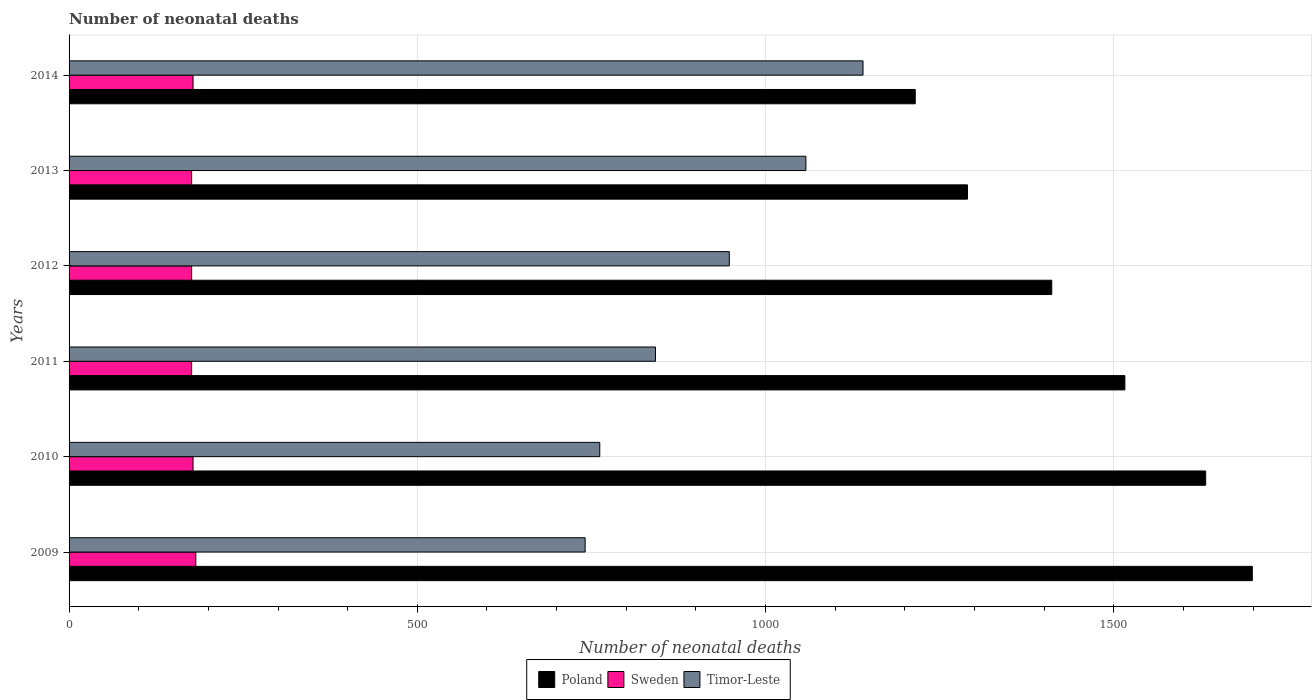Are the number of bars per tick equal to the number of legend labels?
Ensure brevity in your answer.  Yes. How many bars are there on the 4th tick from the top?
Your response must be concise. 3. In how many cases, is the number of bars for a given year not equal to the number of legend labels?
Provide a succinct answer. 0. What is the number of neonatal deaths in in Sweden in 2010?
Make the answer very short. 178. Across all years, what is the maximum number of neonatal deaths in in Poland?
Offer a very short reply. 1699. Across all years, what is the minimum number of neonatal deaths in in Poland?
Keep it short and to the point. 1215. In which year was the number of neonatal deaths in in Sweden maximum?
Your response must be concise. 2009. In which year was the number of neonatal deaths in in Sweden minimum?
Give a very brief answer. 2011. What is the total number of neonatal deaths in in Poland in the graph?
Your answer should be very brief. 8763. What is the difference between the number of neonatal deaths in in Sweden in 2012 and that in 2014?
Ensure brevity in your answer.  -2. What is the difference between the number of neonatal deaths in in Poland in 2010 and the number of neonatal deaths in in Timor-Leste in 2014?
Your response must be concise. 492. What is the average number of neonatal deaths in in Timor-Leste per year?
Your response must be concise. 915.17. In the year 2014, what is the difference between the number of neonatal deaths in in Poland and number of neonatal deaths in in Sweden?
Provide a short and direct response. 1037. What is the ratio of the number of neonatal deaths in in Poland in 2012 to that in 2013?
Your response must be concise. 1.09. Is the number of neonatal deaths in in Sweden in 2013 less than that in 2014?
Make the answer very short. Yes. Is the sum of the number of neonatal deaths in in Timor-Leste in 2009 and 2010 greater than the maximum number of neonatal deaths in in Sweden across all years?
Provide a short and direct response. Yes. What does the 1st bar from the top in 2012 represents?
Your response must be concise. Timor-Leste. Is it the case that in every year, the sum of the number of neonatal deaths in in Timor-Leste and number of neonatal deaths in in Sweden is greater than the number of neonatal deaths in in Poland?
Your response must be concise. No. How many bars are there?
Make the answer very short. 18. Are all the bars in the graph horizontal?
Give a very brief answer. Yes. How many years are there in the graph?
Keep it short and to the point. 6. What is the difference between two consecutive major ticks on the X-axis?
Give a very brief answer. 500. Does the graph contain any zero values?
Your response must be concise. No. Does the graph contain grids?
Keep it short and to the point. Yes. Where does the legend appear in the graph?
Provide a short and direct response. Bottom center. What is the title of the graph?
Your answer should be very brief. Number of neonatal deaths. Does "Colombia" appear as one of the legend labels in the graph?
Your answer should be compact. No. What is the label or title of the X-axis?
Ensure brevity in your answer.  Number of neonatal deaths. What is the label or title of the Y-axis?
Provide a succinct answer. Years. What is the Number of neonatal deaths in Poland in 2009?
Give a very brief answer. 1699. What is the Number of neonatal deaths of Sweden in 2009?
Your answer should be very brief. 182. What is the Number of neonatal deaths in Timor-Leste in 2009?
Give a very brief answer. 741. What is the Number of neonatal deaths of Poland in 2010?
Make the answer very short. 1632. What is the Number of neonatal deaths of Sweden in 2010?
Provide a succinct answer. 178. What is the Number of neonatal deaths of Timor-Leste in 2010?
Provide a succinct answer. 762. What is the Number of neonatal deaths of Poland in 2011?
Make the answer very short. 1516. What is the Number of neonatal deaths of Sweden in 2011?
Your answer should be very brief. 176. What is the Number of neonatal deaths in Timor-Leste in 2011?
Ensure brevity in your answer.  842. What is the Number of neonatal deaths in Poland in 2012?
Keep it short and to the point. 1411. What is the Number of neonatal deaths in Sweden in 2012?
Ensure brevity in your answer.  176. What is the Number of neonatal deaths in Timor-Leste in 2012?
Provide a short and direct response. 948. What is the Number of neonatal deaths in Poland in 2013?
Keep it short and to the point. 1290. What is the Number of neonatal deaths in Sweden in 2013?
Keep it short and to the point. 176. What is the Number of neonatal deaths of Timor-Leste in 2013?
Make the answer very short. 1058. What is the Number of neonatal deaths of Poland in 2014?
Provide a succinct answer. 1215. What is the Number of neonatal deaths in Sweden in 2014?
Provide a short and direct response. 178. What is the Number of neonatal deaths of Timor-Leste in 2014?
Ensure brevity in your answer.  1140. Across all years, what is the maximum Number of neonatal deaths of Poland?
Keep it short and to the point. 1699. Across all years, what is the maximum Number of neonatal deaths of Sweden?
Your response must be concise. 182. Across all years, what is the maximum Number of neonatal deaths of Timor-Leste?
Ensure brevity in your answer.  1140. Across all years, what is the minimum Number of neonatal deaths of Poland?
Give a very brief answer. 1215. Across all years, what is the minimum Number of neonatal deaths of Sweden?
Keep it short and to the point. 176. Across all years, what is the minimum Number of neonatal deaths of Timor-Leste?
Your answer should be very brief. 741. What is the total Number of neonatal deaths in Poland in the graph?
Make the answer very short. 8763. What is the total Number of neonatal deaths of Sweden in the graph?
Ensure brevity in your answer.  1066. What is the total Number of neonatal deaths in Timor-Leste in the graph?
Provide a short and direct response. 5491. What is the difference between the Number of neonatal deaths of Poland in 2009 and that in 2010?
Give a very brief answer. 67. What is the difference between the Number of neonatal deaths of Sweden in 2009 and that in 2010?
Make the answer very short. 4. What is the difference between the Number of neonatal deaths in Poland in 2009 and that in 2011?
Provide a short and direct response. 183. What is the difference between the Number of neonatal deaths of Sweden in 2009 and that in 2011?
Provide a short and direct response. 6. What is the difference between the Number of neonatal deaths of Timor-Leste in 2009 and that in 2011?
Ensure brevity in your answer.  -101. What is the difference between the Number of neonatal deaths of Poland in 2009 and that in 2012?
Your answer should be compact. 288. What is the difference between the Number of neonatal deaths in Timor-Leste in 2009 and that in 2012?
Provide a short and direct response. -207. What is the difference between the Number of neonatal deaths of Poland in 2009 and that in 2013?
Ensure brevity in your answer.  409. What is the difference between the Number of neonatal deaths in Timor-Leste in 2009 and that in 2013?
Ensure brevity in your answer.  -317. What is the difference between the Number of neonatal deaths of Poland in 2009 and that in 2014?
Offer a very short reply. 484. What is the difference between the Number of neonatal deaths in Sweden in 2009 and that in 2014?
Give a very brief answer. 4. What is the difference between the Number of neonatal deaths of Timor-Leste in 2009 and that in 2014?
Provide a succinct answer. -399. What is the difference between the Number of neonatal deaths in Poland in 2010 and that in 2011?
Your response must be concise. 116. What is the difference between the Number of neonatal deaths in Sweden in 2010 and that in 2011?
Make the answer very short. 2. What is the difference between the Number of neonatal deaths of Timor-Leste in 2010 and that in 2011?
Keep it short and to the point. -80. What is the difference between the Number of neonatal deaths of Poland in 2010 and that in 2012?
Your answer should be very brief. 221. What is the difference between the Number of neonatal deaths of Sweden in 2010 and that in 2012?
Offer a very short reply. 2. What is the difference between the Number of neonatal deaths of Timor-Leste in 2010 and that in 2012?
Provide a succinct answer. -186. What is the difference between the Number of neonatal deaths of Poland in 2010 and that in 2013?
Give a very brief answer. 342. What is the difference between the Number of neonatal deaths in Sweden in 2010 and that in 2013?
Offer a terse response. 2. What is the difference between the Number of neonatal deaths in Timor-Leste in 2010 and that in 2013?
Give a very brief answer. -296. What is the difference between the Number of neonatal deaths of Poland in 2010 and that in 2014?
Offer a terse response. 417. What is the difference between the Number of neonatal deaths in Sweden in 2010 and that in 2014?
Offer a very short reply. 0. What is the difference between the Number of neonatal deaths in Timor-Leste in 2010 and that in 2014?
Keep it short and to the point. -378. What is the difference between the Number of neonatal deaths in Poland in 2011 and that in 2012?
Provide a succinct answer. 105. What is the difference between the Number of neonatal deaths in Sweden in 2011 and that in 2012?
Your answer should be very brief. 0. What is the difference between the Number of neonatal deaths of Timor-Leste in 2011 and that in 2012?
Offer a terse response. -106. What is the difference between the Number of neonatal deaths of Poland in 2011 and that in 2013?
Make the answer very short. 226. What is the difference between the Number of neonatal deaths in Sweden in 2011 and that in 2013?
Your answer should be very brief. 0. What is the difference between the Number of neonatal deaths of Timor-Leste in 2011 and that in 2013?
Keep it short and to the point. -216. What is the difference between the Number of neonatal deaths in Poland in 2011 and that in 2014?
Provide a succinct answer. 301. What is the difference between the Number of neonatal deaths of Timor-Leste in 2011 and that in 2014?
Your answer should be compact. -298. What is the difference between the Number of neonatal deaths in Poland in 2012 and that in 2013?
Your answer should be compact. 121. What is the difference between the Number of neonatal deaths of Timor-Leste in 2012 and that in 2013?
Offer a very short reply. -110. What is the difference between the Number of neonatal deaths in Poland in 2012 and that in 2014?
Ensure brevity in your answer.  196. What is the difference between the Number of neonatal deaths in Sweden in 2012 and that in 2014?
Provide a succinct answer. -2. What is the difference between the Number of neonatal deaths in Timor-Leste in 2012 and that in 2014?
Offer a terse response. -192. What is the difference between the Number of neonatal deaths in Poland in 2013 and that in 2014?
Offer a terse response. 75. What is the difference between the Number of neonatal deaths in Timor-Leste in 2013 and that in 2014?
Ensure brevity in your answer.  -82. What is the difference between the Number of neonatal deaths of Poland in 2009 and the Number of neonatal deaths of Sweden in 2010?
Your answer should be compact. 1521. What is the difference between the Number of neonatal deaths of Poland in 2009 and the Number of neonatal deaths of Timor-Leste in 2010?
Offer a very short reply. 937. What is the difference between the Number of neonatal deaths of Sweden in 2009 and the Number of neonatal deaths of Timor-Leste in 2010?
Your answer should be compact. -580. What is the difference between the Number of neonatal deaths of Poland in 2009 and the Number of neonatal deaths of Sweden in 2011?
Keep it short and to the point. 1523. What is the difference between the Number of neonatal deaths in Poland in 2009 and the Number of neonatal deaths in Timor-Leste in 2011?
Your answer should be compact. 857. What is the difference between the Number of neonatal deaths in Sweden in 2009 and the Number of neonatal deaths in Timor-Leste in 2011?
Your response must be concise. -660. What is the difference between the Number of neonatal deaths in Poland in 2009 and the Number of neonatal deaths in Sweden in 2012?
Your response must be concise. 1523. What is the difference between the Number of neonatal deaths of Poland in 2009 and the Number of neonatal deaths of Timor-Leste in 2012?
Make the answer very short. 751. What is the difference between the Number of neonatal deaths of Sweden in 2009 and the Number of neonatal deaths of Timor-Leste in 2012?
Keep it short and to the point. -766. What is the difference between the Number of neonatal deaths in Poland in 2009 and the Number of neonatal deaths in Sweden in 2013?
Ensure brevity in your answer.  1523. What is the difference between the Number of neonatal deaths in Poland in 2009 and the Number of neonatal deaths in Timor-Leste in 2013?
Give a very brief answer. 641. What is the difference between the Number of neonatal deaths in Sweden in 2009 and the Number of neonatal deaths in Timor-Leste in 2013?
Provide a short and direct response. -876. What is the difference between the Number of neonatal deaths of Poland in 2009 and the Number of neonatal deaths of Sweden in 2014?
Offer a terse response. 1521. What is the difference between the Number of neonatal deaths of Poland in 2009 and the Number of neonatal deaths of Timor-Leste in 2014?
Ensure brevity in your answer.  559. What is the difference between the Number of neonatal deaths of Sweden in 2009 and the Number of neonatal deaths of Timor-Leste in 2014?
Make the answer very short. -958. What is the difference between the Number of neonatal deaths in Poland in 2010 and the Number of neonatal deaths in Sweden in 2011?
Provide a short and direct response. 1456. What is the difference between the Number of neonatal deaths of Poland in 2010 and the Number of neonatal deaths of Timor-Leste in 2011?
Offer a very short reply. 790. What is the difference between the Number of neonatal deaths of Sweden in 2010 and the Number of neonatal deaths of Timor-Leste in 2011?
Offer a terse response. -664. What is the difference between the Number of neonatal deaths of Poland in 2010 and the Number of neonatal deaths of Sweden in 2012?
Provide a succinct answer. 1456. What is the difference between the Number of neonatal deaths in Poland in 2010 and the Number of neonatal deaths in Timor-Leste in 2012?
Provide a succinct answer. 684. What is the difference between the Number of neonatal deaths of Sweden in 2010 and the Number of neonatal deaths of Timor-Leste in 2012?
Provide a succinct answer. -770. What is the difference between the Number of neonatal deaths of Poland in 2010 and the Number of neonatal deaths of Sweden in 2013?
Provide a short and direct response. 1456. What is the difference between the Number of neonatal deaths of Poland in 2010 and the Number of neonatal deaths of Timor-Leste in 2013?
Provide a succinct answer. 574. What is the difference between the Number of neonatal deaths in Sweden in 2010 and the Number of neonatal deaths in Timor-Leste in 2013?
Keep it short and to the point. -880. What is the difference between the Number of neonatal deaths in Poland in 2010 and the Number of neonatal deaths in Sweden in 2014?
Offer a very short reply. 1454. What is the difference between the Number of neonatal deaths in Poland in 2010 and the Number of neonatal deaths in Timor-Leste in 2014?
Your answer should be compact. 492. What is the difference between the Number of neonatal deaths in Sweden in 2010 and the Number of neonatal deaths in Timor-Leste in 2014?
Offer a very short reply. -962. What is the difference between the Number of neonatal deaths of Poland in 2011 and the Number of neonatal deaths of Sweden in 2012?
Offer a terse response. 1340. What is the difference between the Number of neonatal deaths of Poland in 2011 and the Number of neonatal deaths of Timor-Leste in 2012?
Provide a succinct answer. 568. What is the difference between the Number of neonatal deaths in Sweden in 2011 and the Number of neonatal deaths in Timor-Leste in 2012?
Keep it short and to the point. -772. What is the difference between the Number of neonatal deaths of Poland in 2011 and the Number of neonatal deaths of Sweden in 2013?
Give a very brief answer. 1340. What is the difference between the Number of neonatal deaths of Poland in 2011 and the Number of neonatal deaths of Timor-Leste in 2013?
Your response must be concise. 458. What is the difference between the Number of neonatal deaths of Sweden in 2011 and the Number of neonatal deaths of Timor-Leste in 2013?
Your answer should be compact. -882. What is the difference between the Number of neonatal deaths of Poland in 2011 and the Number of neonatal deaths of Sweden in 2014?
Offer a very short reply. 1338. What is the difference between the Number of neonatal deaths in Poland in 2011 and the Number of neonatal deaths in Timor-Leste in 2014?
Give a very brief answer. 376. What is the difference between the Number of neonatal deaths of Sweden in 2011 and the Number of neonatal deaths of Timor-Leste in 2014?
Keep it short and to the point. -964. What is the difference between the Number of neonatal deaths of Poland in 2012 and the Number of neonatal deaths of Sweden in 2013?
Your response must be concise. 1235. What is the difference between the Number of neonatal deaths in Poland in 2012 and the Number of neonatal deaths in Timor-Leste in 2013?
Provide a short and direct response. 353. What is the difference between the Number of neonatal deaths of Sweden in 2012 and the Number of neonatal deaths of Timor-Leste in 2013?
Your answer should be very brief. -882. What is the difference between the Number of neonatal deaths in Poland in 2012 and the Number of neonatal deaths in Sweden in 2014?
Keep it short and to the point. 1233. What is the difference between the Number of neonatal deaths in Poland in 2012 and the Number of neonatal deaths in Timor-Leste in 2014?
Keep it short and to the point. 271. What is the difference between the Number of neonatal deaths in Sweden in 2012 and the Number of neonatal deaths in Timor-Leste in 2014?
Offer a terse response. -964. What is the difference between the Number of neonatal deaths of Poland in 2013 and the Number of neonatal deaths of Sweden in 2014?
Your answer should be compact. 1112. What is the difference between the Number of neonatal deaths of Poland in 2013 and the Number of neonatal deaths of Timor-Leste in 2014?
Give a very brief answer. 150. What is the difference between the Number of neonatal deaths in Sweden in 2013 and the Number of neonatal deaths in Timor-Leste in 2014?
Give a very brief answer. -964. What is the average Number of neonatal deaths of Poland per year?
Offer a very short reply. 1460.5. What is the average Number of neonatal deaths in Sweden per year?
Provide a succinct answer. 177.67. What is the average Number of neonatal deaths of Timor-Leste per year?
Ensure brevity in your answer.  915.17. In the year 2009, what is the difference between the Number of neonatal deaths of Poland and Number of neonatal deaths of Sweden?
Give a very brief answer. 1517. In the year 2009, what is the difference between the Number of neonatal deaths in Poland and Number of neonatal deaths in Timor-Leste?
Give a very brief answer. 958. In the year 2009, what is the difference between the Number of neonatal deaths of Sweden and Number of neonatal deaths of Timor-Leste?
Your answer should be very brief. -559. In the year 2010, what is the difference between the Number of neonatal deaths in Poland and Number of neonatal deaths in Sweden?
Keep it short and to the point. 1454. In the year 2010, what is the difference between the Number of neonatal deaths in Poland and Number of neonatal deaths in Timor-Leste?
Provide a short and direct response. 870. In the year 2010, what is the difference between the Number of neonatal deaths of Sweden and Number of neonatal deaths of Timor-Leste?
Provide a short and direct response. -584. In the year 2011, what is the difference between the Number of neonatal deaths in Poland and Number of neonatal deaths in Sweden?
Ensure brevity in your answer.  1340. In the year 2011, what is the difference between the Number of neonatal deaths in Poland and Number of neonatal deaths in Timor-Leste?
Your answer should be very brief. 674. In the year 2011, what is the difference between the Number of neonatal deaths of Sweden and Number of neonatal deaths of Timor-Leste?
Your response must be concise. -666. In the year 2012, what is the difference between the Number of neonatal deaths of Poland and Number of neonatal deaths of Sweden?
Give a very brief answer. 1235. In the year 2012, what is the difference between the Number of neonatal deaths in Poland and Number of neonatal deaths in Timor-Leste?
Offer a very short reply. 463. In the year 2012, what is the difference between the Number of neonatal deaths in Sweden and Number of neonatal deaths in Timor-Leste?
Provide a short and direct response. -772. In the year 2013, what is the difference between the Number of neonatal deaths in Poland and Number of neonatal deaths in Sweden?
Your answer should be compact. 1114. In the year 2013, what is the difference between the Number of neonatal deaths of Poland and Number of neonatal deaths of Timor-Leste?
Your response must be concise. 232. In the year 2013, what is the difference between the Number of neonatal deaths in Sweden and Number of neonatal deaths in Timor-Leste?
Give a very brief answer. -882. In the year 2014, what is the difference between the Number of neonatal deaths in Poland and Number of neonatal deaths in Sweden?
Provide a short and direct response. 1037. In the year 2014, what is the difference between the Number of neonatal deaths of Poland and Number of neonatal deaths of Timor-Leste?
Your answer should be very brief. 75. In the year 2014, what is the difference between the Number of neonatal deaths of Sweden and Number of neonatal deaths of Timor-Leste?
Provide a succinct answer. -962. What is the ratio of the Number of neonatal deaths in Poland in 2009 to that in 2010?
Ensure brevity in your answer.  1.04. What is the ratio of the Number of neonatal deaths in Sweden in 2009 to that in 2010?
Keep it short and to the point. 1.02. What is the ratio of the Number of neonatal deaths of Timor-Leste in 2009 to that in 2010?
Give a very brief answer. 0.97. What is the ratio of the Number of neonatal deaths in Poland in 2009 to that in 2011?
Ensure brevity in your answer.  1.12. What is the ratio of the Number of neonatal deaths in Sweden in 2009 to that in 2011?
Your response must be concise. 1.03. What is the ratio of the Number of neonatal deaths in Timor-Leste in 2009 to that in 2011?
Your answer should be very brief. 0.88. What is the ratio of the Number of neonatal deaths of Poland in 2009 to that in 2012?
Your answer should be compact. 1.2. What is the ratio of the Number of neonatal deaths in Sweden in 2009 to that in 2012?
Ensure brevity in your answer.  1.03. What is the ratio of the Number of neonatal deaths in Timor-Leste in 2009 to that in 2012?
Provide a succinct answer. 0.78. What is the ratio of the Number of neonatal deaths of Poland in 2009 to that in 2013?
Offer a terse response. 1.32. What is the ratio of the Number of neonatal deaths in Sweden in 2009 to that in 2013?
Make the answer very short. 1.03. What is the ratio of the Number of neonatal deaths of Timor-Leste in 2009 to that in 2013?
Ensure brevity in your answer.  0.7. What is the ratio of the Number of neonatal deaths of Poland in 2009 to that in 2014?
Provide a succinct answer. 1.4. What is the ratio of the Number of neonatal deaths of Sweden in 2009 to that in 2014?
Provide a succinct answer. 1.02. What is the ratio of the Number of neonatal deaths of Timor-Leste in 2009 to that in 2014?
Make the answer very short. 0.65. What is the ratio of the Number of neonatal deaths of Poland in 2010 to that in 2011?
Provide a succinct answer. 1.08. What is the ratio of the Number of neonatal deaths in Sweden in 2010 to that in 2011?
Keep it short and to the point. 1.01. What is the ratio of the Number of neonatal deaths of Timor-Leste in 2010 to that in 2011?
Your answer should be very brief. 0.91. What is the ratio of the Number of neonatal deaths in Poland in 2010 to that in 2012?
Offer a very short reply. 1.16. What is the ratio of the Number of neonatal deaths of Sweden in 2010 to that in 2012?
Give a very brief answer. 1.01. What is the ratio of the Number of neonatal deaths of Timor-Leste in 2010 to that in 2012?
Ensure brevity in your answer.  0.8. What is the ratio of the Number of neonatal deaths of Poland in 2010 to that in 2013?
Provide a short and direct response. 1.27. What is the ratio of the Number of neonatal deaths in Sweden in 2010 to that in 2013?
Your answer should be very brief. 1.01. What is the ratio of the Number of neonatal deaths in Timor-Leste in 2010 to that in 2013?
Offer a terse response. 0.72. What is the ratio of the Number of neonatal deaths in Poland in 2010 to that in 2014?
Provide a short and direct response. 1.34. What is the ratio of the Number of neonatal deaths in Sweden in 2010 to that in 2014?
Keep it short and to the point. 1. What is the ratio of the Number of neonatal deaths in Timor-Leste in 2010 to that in 2014?
Give a very brief answer. 0.67. What is the ratio of the Number of neonatal deaths in Poland in 2011 to that in 2012?
Your answer should be compact. 1.07. What is the ratio of the Number of neonatal deaths in Timor-Leste in 2011 to that in 2012?
Provide a succinct answer. 0.89. What is the ratio of the Number of neonatal deaths in Poland in 2011 to that in 2013?
Keep it short and to the point. 1.18. What is the ratio of the Number of neonatal deaths of Timor-Leste in 2011 to that in 2013?
Keep it short and to the point. 0.8. What is the ratio of the Number of neonatal deaths of Poland in 2011 to that in 2014?
Make the answer very short. 1.25. What is the ratio of the Number of neonatal deaths of Timor-Leste in 2011 to that in 2014?
Provide a succinct answer. 0.74. What is the ratio of the Number of neonatal deaths of Poland in 2012 to that in 2013?
Offer a terse response. 1.09. What is the ratio of the Number of neonatal deaths of Sweden in 2012 to that in 2013?
Your answer should be very brief. 1. What is the ratio of the Number of neonatal deaths of Timor-Leste in 2012 to that in 2013?
Your response must be concise. 0.9. What is the ratio of the Number of neonatal deaths of Poland in 2012 to that in 2014?
Make the answer very short. 1.16. What is the ratio of the Number of neonatal deaths in Timor-Leste in 2012 to that in 2014?
Provide a succinct answer. 0.83. What is the ratio of the Number of neonatal deaths in Poland in 2013 to that in 2014?
Offer a terse response. 1.06. What is the ratio of the Number of neonatal deaths in Timor-Leste in 2013 to that in 2014?
Your response must be concise. 0.93. What is the difference between the highest and the second highest Number of neonatal deaths in Timor-Leste?
Your answer should be compact. 82. What is the difference between the highest and the lowest Number of neonatal deaths in Poland?
Ensure brevity in your answer.  484. What is the difference between the highest and the lowest Number of neonatal deaths in Timor-Leste?
Offer a terse response. 399. 